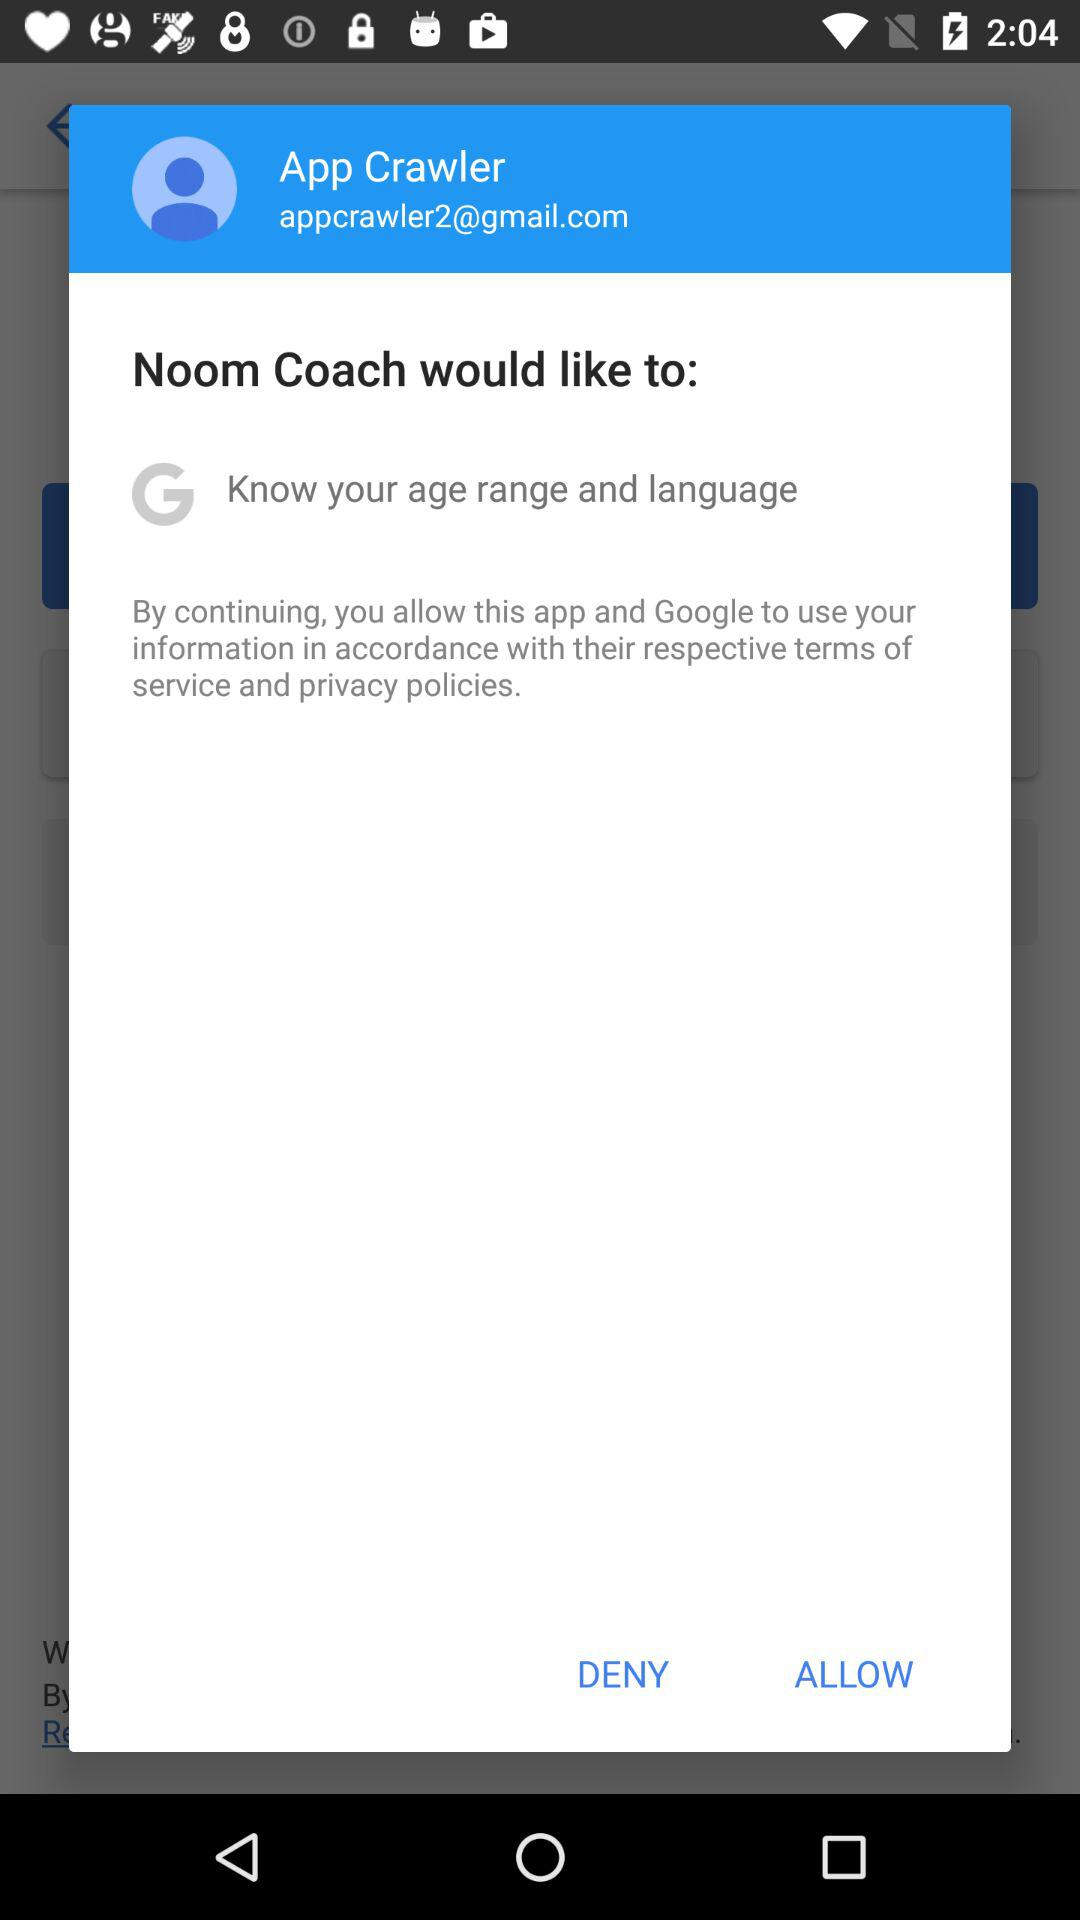What is the user name? The user name is App Crawler. 